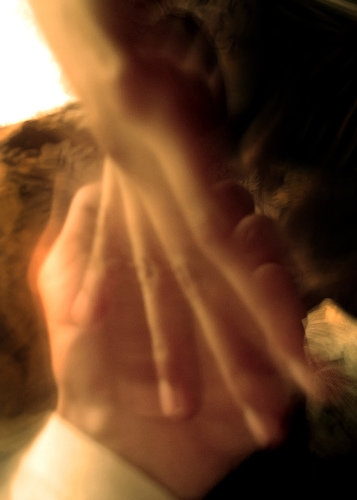<image>
Is the palm under the wrist? Yes. The palm is positioned underneath the wrist, with the wrist above it in the vertical space. 